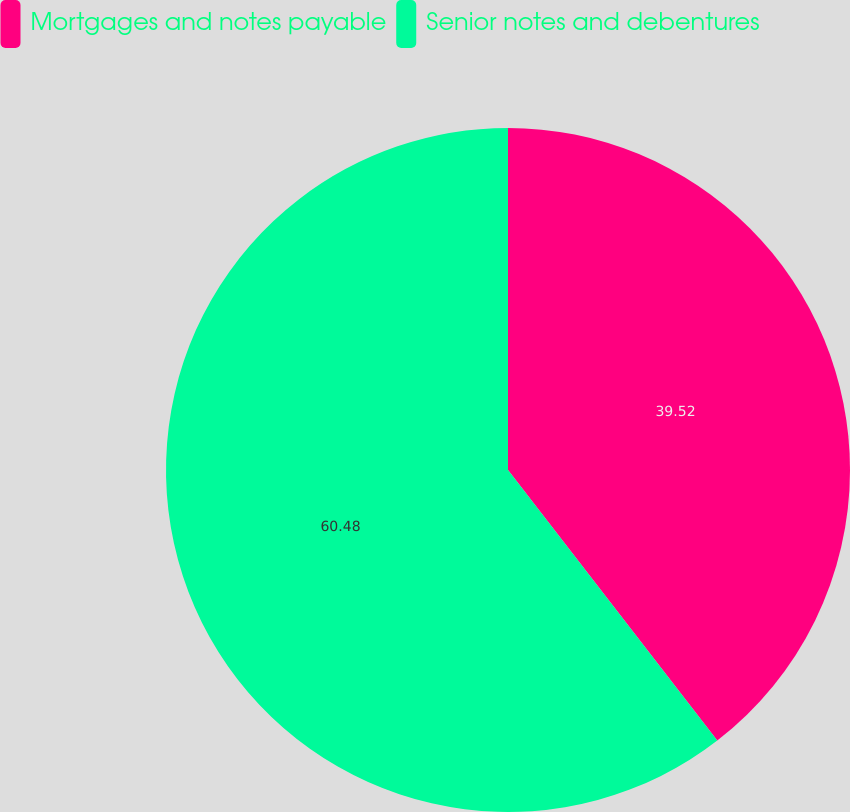<chart> <loc_0><loc_0><loc_500><loc_500><pie_chart><fcel>Mortgages and notes payable<fcel>Senior notes and debentures<nl><fcel>39.52%<fcel>60.48%<nl></chart> 